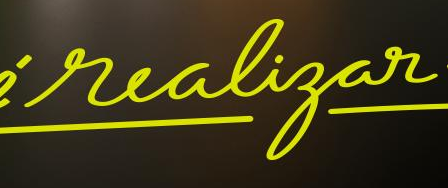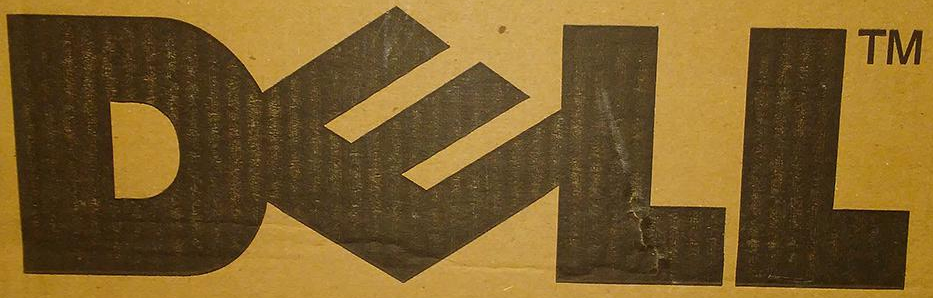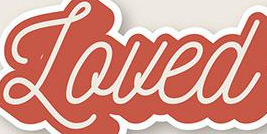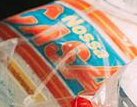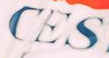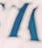What words are shown in these images in order, separated by a semicolon? realigar; DELL; Loued; CASA; CES; # 